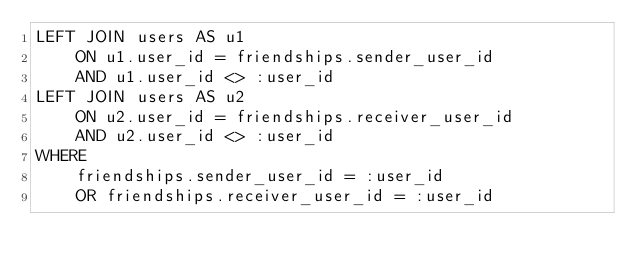Convert code to text. <code><loc_0><loc_0><loc_500><loc_500><_SQL_>LEFT JOIN users AS u1
    ON u1.user_id = friendships.sender_user_id
    AND u1.user_id <> :user_id
LEFT JOIN users AS u2
    ON u2.user_id = friendships.receiver_user_id
    AND u2.user_id <> :user_id
WHERE 
    friendships.sender_user_id = :user_id
    OR friendships.receiver_user_id = :user_id
</code> 